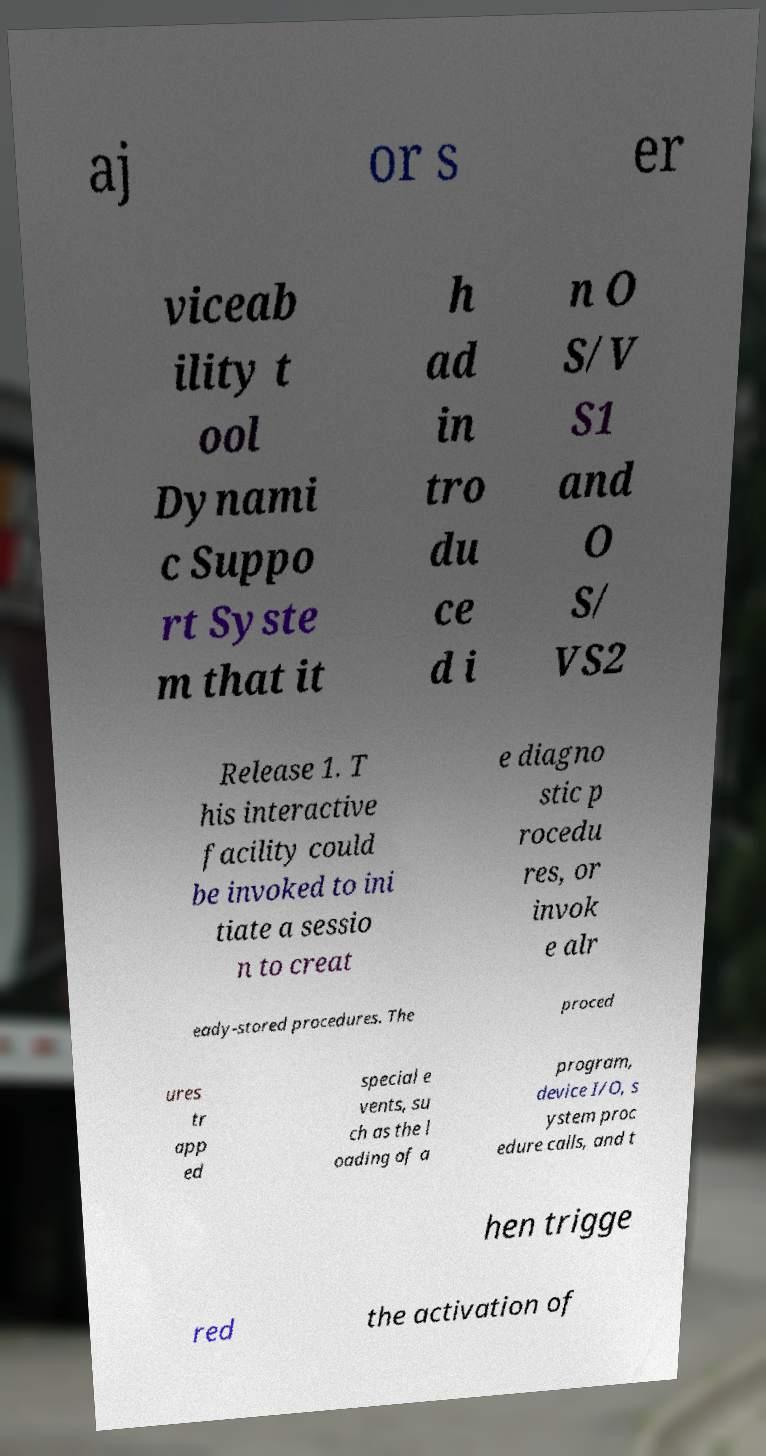Can you accurately transcribe the text from the provided image for me? aj or s er viceab ility t ool Dynami c Suppo rt Syste m that it h ad in tro du ce d i n O S/V S1 and O S/ VS2 Release 1. T his interactive facility could be invoked to ini tiate a sessio n to creat e diagno stic p rocedu res, or invok e alr eady-stored procedures. The proced ures tr app ed special e vents, su ch as the l oading of a program, device I/O, s ystem proc edure calls, and t hen trigge red the activation of 